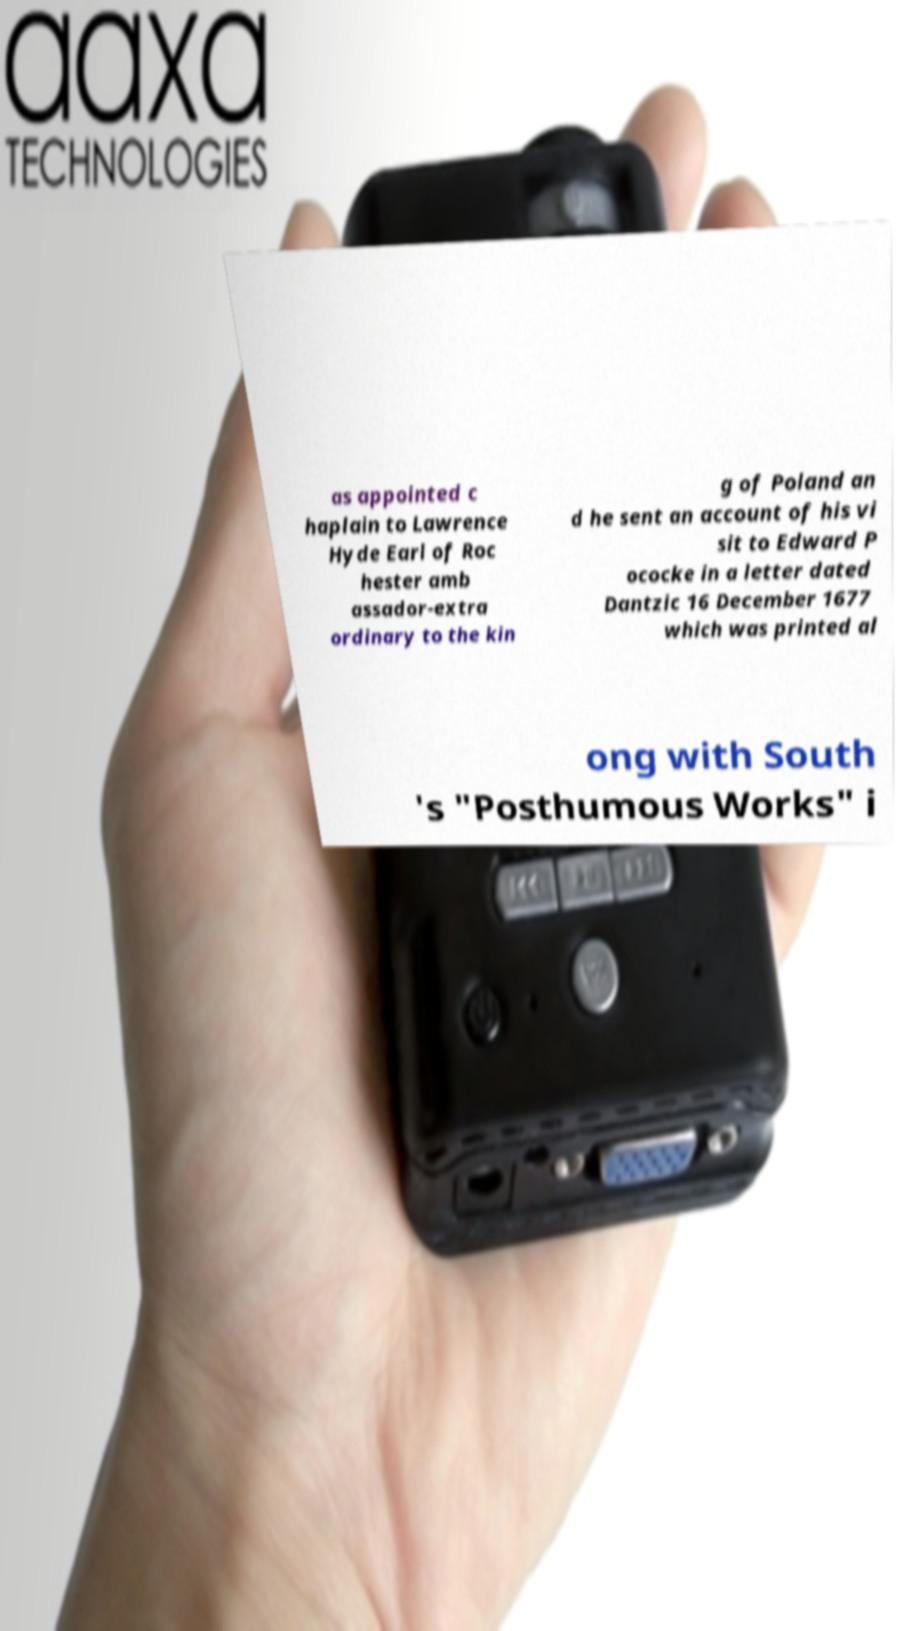Can you accurately transcribe the text from the provided image for me? as appointed c haplain to Lawrence Hyde Earl of Roc hester amb assador-extra ordinary to the kin g of Poland an d he sent an account of his vi sit to Edward P ococke in a letter dated Dantzic 16 December 1677 which was printed al ong with South 's "Posthumous Works" i 